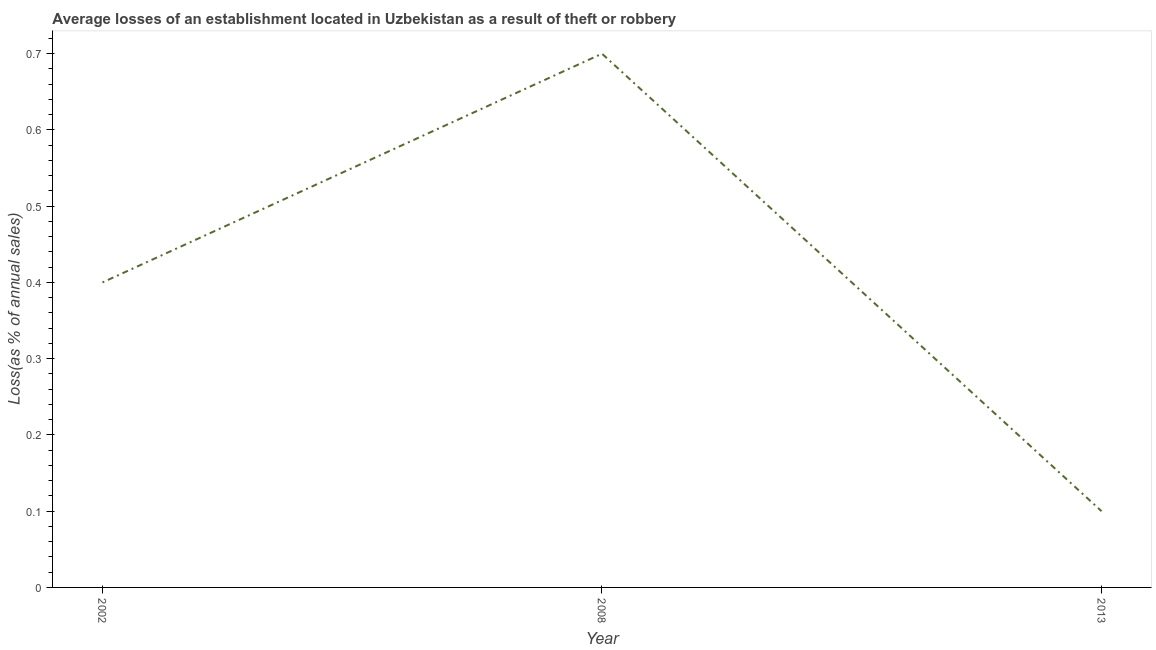Across all years, what is the minimum losses due to theft?
Keep it short and to the point. 0.1. In which year was the losses due to theft maximum?
Your response must be concise. 2008. What is the sum of the losses due to theft?
Provide a succinct answer. 1.2. What is the difference between the losses due to theft in 2002 and 2008?
Ensure brevity in your answer.  -0.3. What is the average losses due to theft per year?
Your answer should be compact. 0.4. What is the median losses due to theft?
Your response must be concise. 0.4. Do a majority of the years between 2013 and 2002 (inclusive) have losses due to theft greater than 0.42000000000000004 %?
Give a very brief answer. No. Is the difference between the losses due to theft in 2002 and 2013 greater than the difference between any two years?
Give a very brief answer. No. What is the difference between the highest and the second highest losses due to theft?
Ensure brevity in your answer.  0.3. Is the sum of the losses due to theft in 2008 and 2013 greater than the maximum losses due to theft across all years?
Your response must be concise. Yes. What is the difference between the highest and the lowest losses due to theft?
Provide a succinct answer. 0.6. Are the values on the major ticks of Y-axis written in scientific E-notation?
Ensure brevity in your answer.  No. Does the graph contain any zero values?
Ensure brevity in your answer.  No. Does the graph contain grids?
Ensure brevity in your answer.  No. What is the title of the graph?
Give a very brief answer. Average losses of an establishment located in Uzbekistan as a result of theft or robbery. What is the label or title of the Y-axis?
Offer a terse response. Loss(as % of annual sales). What is the Loss(as % of annual sales) of 2002?
Offer a very short reply. 0.4. What is the difference between the Loss(as % of annual sales) in 2002 and 2008?
Make the answer very short. -0.3. What is the difference between the Loss(as % of annual sales) in 2008 and 2013?
Provide a short and direct response. 0.6. What is the ratio of the Loss(as % of annual sales) in 2002 to that in 2008?
Your answer should be very brief. 0.57. What is the ratio of the Loss(as % of annual sales) in 2002 to that in 2013?
Your answer should be compact. 4. 